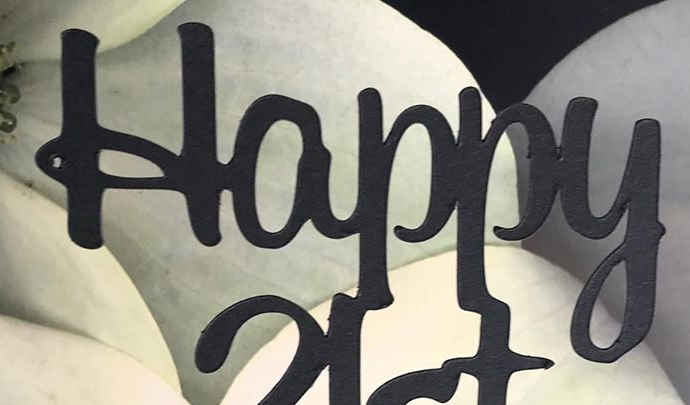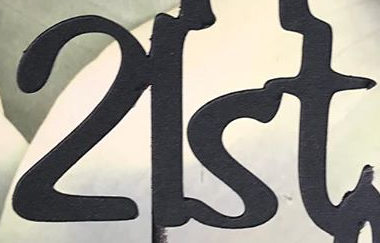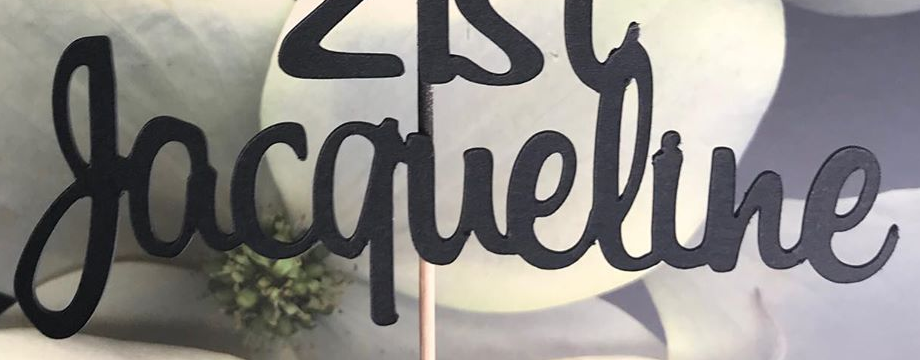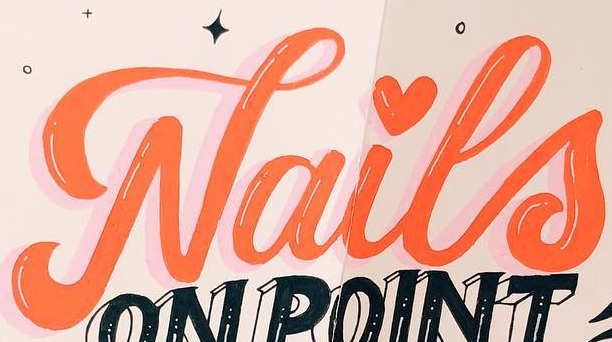Transcribe the words shown in these images in order, separated by a semicolon. Happy; 21st; Jacqueline; Nails 